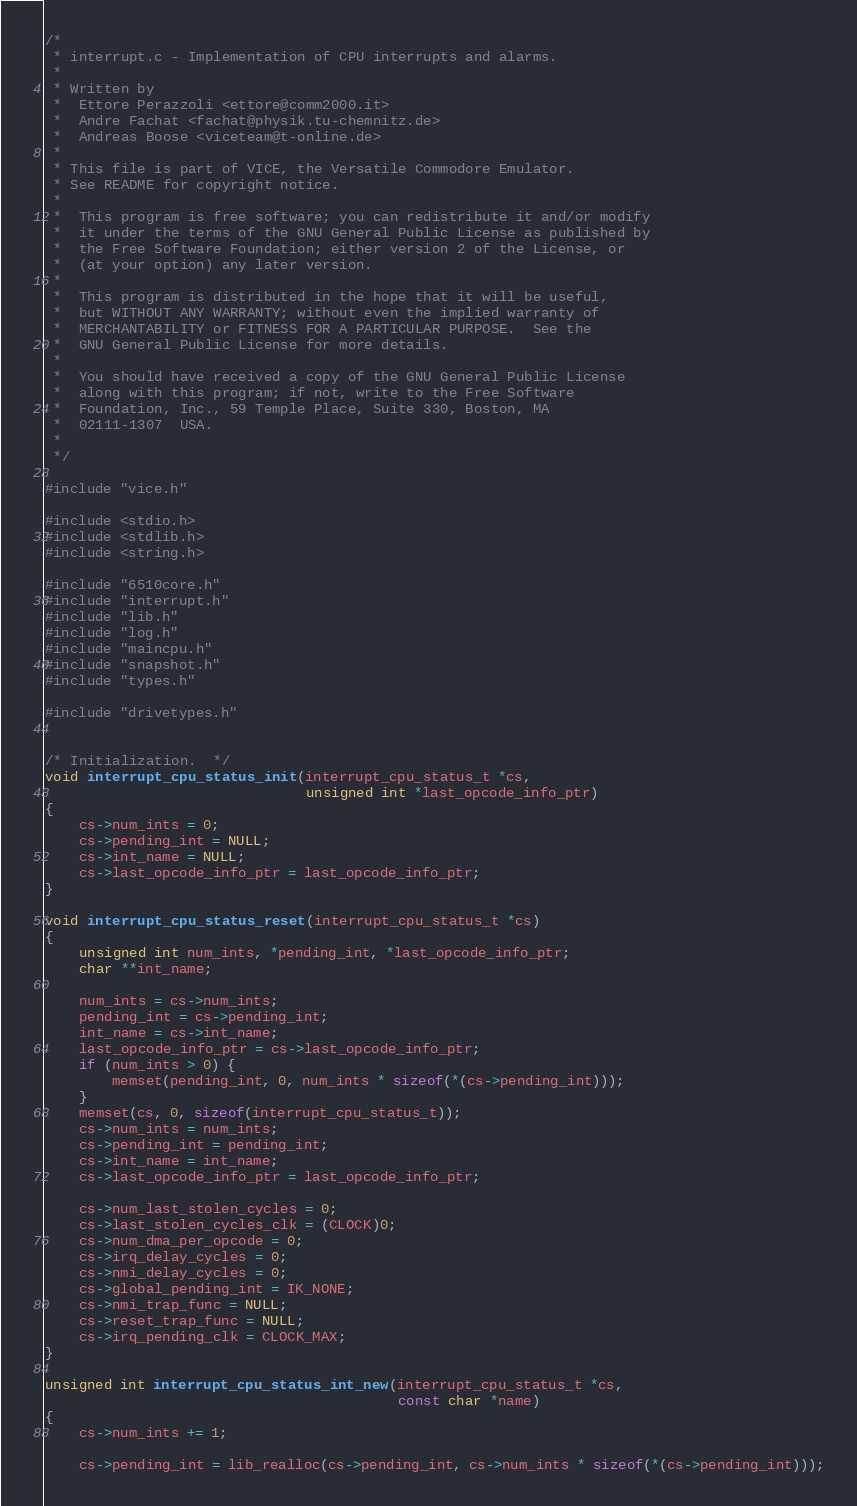<code> <loc_0><loc_0><loc_500><loc_500><_C_>/*
 * interrupt.c - Implementation of CPU interrupts and alarms.
 *
 * Written by
 *  Ettore Perazzoli <ettore@comm2000.it>
 *  Andre Fachat <fachat@physik.tu-chemnitz.de>
 *  Andreas Boose <viceteam@t-online.de>
 *
 * This file is part of VICE, the Versatile Commodore Emulator.
 * See README for copyright notice.
 *
 *  This program is free software; you can redistribute it and/or modify
 *  it under the terms of the GNU General Public License as published by
 *  the Free Software Foundation; either version 2 of the License, or
 *  (at your option) any later version.
 *
 *  This program is distributed in the hope that it will be useful,
 *  but WITHOUT ANY WARRANTY; without even the implied warranty of
 *  MERCHANTABILITY or FITNESS FOR A PARTICULAR PURPOSE.  See the
 *  GNU General Public License for more details.
 *
 *  You should have received a copy of the GNU General Public License
 *  along with this program; if not, write to the Free Software
 *  Foundation, Inc., 59 Temple Place, Suite 330, Boston, MA
 *  02111-1307  USA.
 *
 */

#include "vice.h"

#include <stdio.h>
#include <stdlib.h>
#include <string.h>

#include "6510core.h"
#include "interrupt.h"
#include "lib.h"
#include "log.h"
#include "maincpu.h"
#include "snapshot.h"
#include "types.h"

#include "drivetypes.h"


/* Initialization.  */
void interrupt_cpu_status_init(interrupt_cpu_status_t *cs,
                               unsigned int *last_opcode_info_ptr)
{
    cs->num_ints = 0;
    cs->pending_int = NULL;
    cs->int_name = NULL;
    cs->last_opcode_info_ptr = last_opcode_info_ptr;
}

void interrupt_cpu_status_reset(interrupt_cpu_status_t *cs)
{
    unsigned int num_ints, *pending_int, *last_opcode_info_ptr;
    char **int_name;

    num_ints = cs->num_ints;
    pending_int = cs->pending_int;
    int_name = cs->int_name;
    last_opcode_info_ptr = cs->last_opcode_info_ptr;
    if (num_ints > 0) {
        memset(pending_int, 0, num_ints * sizeof(*(cs->pending_int)));
    }
    memset(cs, 0, sizeof(interrupt_cpu_status_t));
    cs->num_ints = num_ints;
    cs->pending_int = pending_int;
    cs->int_name = int_name;
    cs->last_opcode_info_ptr = last_opcode_info_ptr;

    cs->num_last_stolen_cycles = 0;
    cs->last_stolen_cycles_clk = (CLOCK)0;
    cs->num_dma_per_opcode = 0;
    cs->irq_delay_cycles = 0;
    cs->nmi_delay_cycles = 0;
    cs->global_pending_int = IK_NONE;
    cs->nmi_trap_func = NULL;
    cs->reset_trap_func = NULL;
    cs->irq_pending_clk = CLOCK_MAX;
}

unsigned int interrupt_cpu_status_int_new(interrupt_cpu_status_t *cs,
                                          const char *name)
{
    cs->num_ints += 1;

    cs->pending_int = lib_realloc(cs->pending_int, cs->num_ints * sizeof(*(cs->pending_int)));</code> 